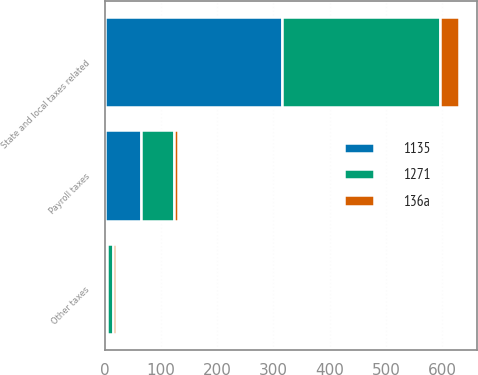Convert chart to OTSL. <chart><loc_0><loc_0><loc_500><loc_500><stacked_bar_chart><ecel><fcel>State and local taxes related<fcel>Payroll taxes<fcel>Other taxes<nl><fcel>1135<fcel>315<fcel>65<fcel>5<nl><fcel>1271<fcel>282<fcel>59<fcel>10<nl><fcel>136a<fcel>33<fcel>6<fcel>5<nl></chart> 